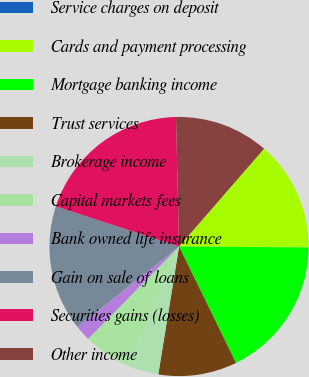Convert chart to OTSL. <chart><loc_0><loc_0><loc_500><loc_500><pie_chart><fcel>Service charges on deposit<fcel>Cards and payment processing<fcel>Mortgage banking income<fcel>Trust services<fcel>Brokerage income<fcel>Capital markets fees<fcel>Bank owned life insurance<fcel>Gain on sale of loans<fcel>Securities gains (losses)<fcel>Other income<nl><fcel>0.0%<fcel>13.72%<fcel>17.64%<fcel>9.8%<fcel>3.92%<fcel>5.88%<fcel>1.96%<fcel>15.68%<fcel>19.6%<fcel>11.76%<nl></chart> 